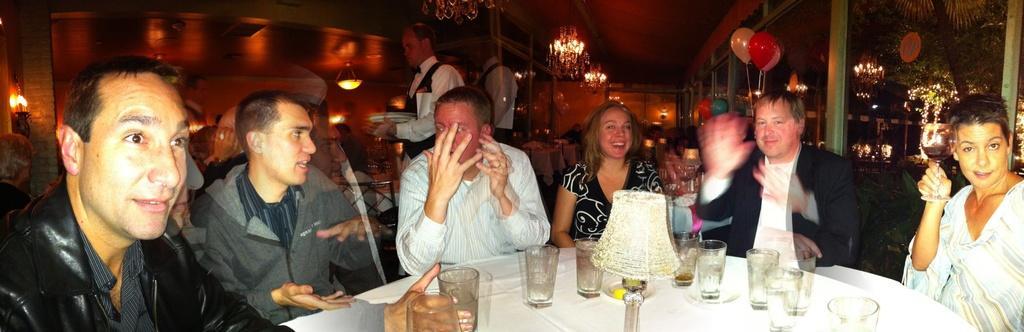How would you summarize this image in a sentence or two? In this image, we can see people sitting on the chairs and there are glasses and a light are placed on the table and in the background, we can see balloons on door. 